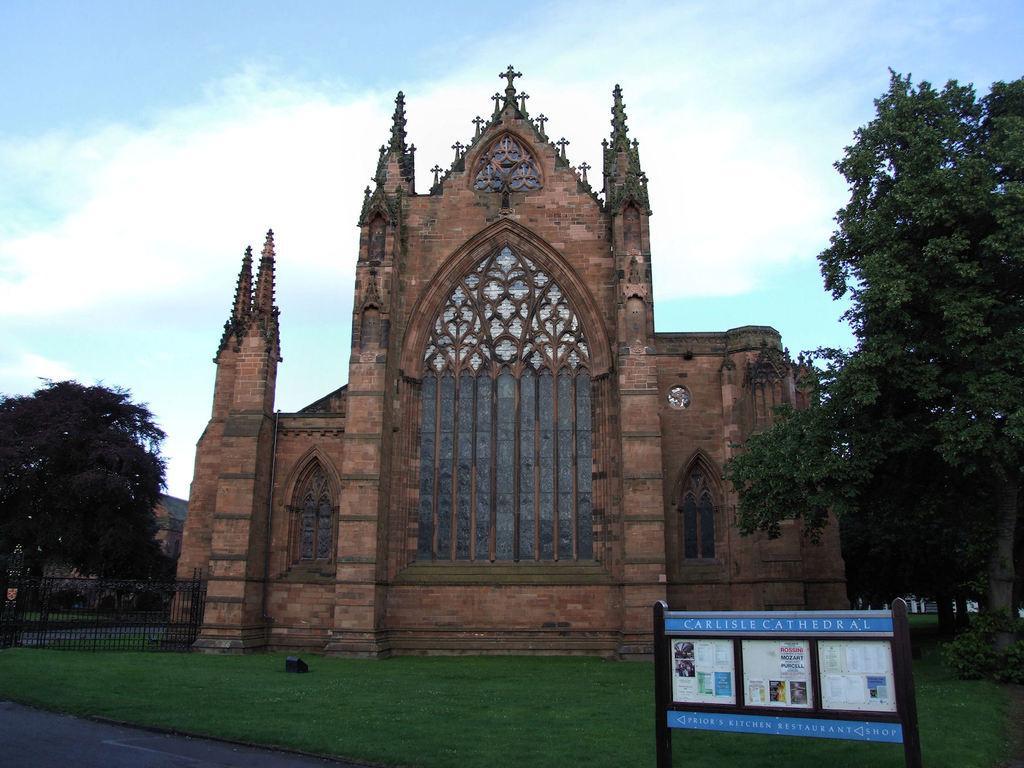How would you summarize this image in a sentence or two? This picture might be taken outside of the building. In this image, on the right side, we can see some trees and plants, we can also see a hoardings. On the left side, we can also see some trees, buildings, metal fence. In the middle there is a building, door, window. On top there is a sky, at the bottom there is a grass and a road. 